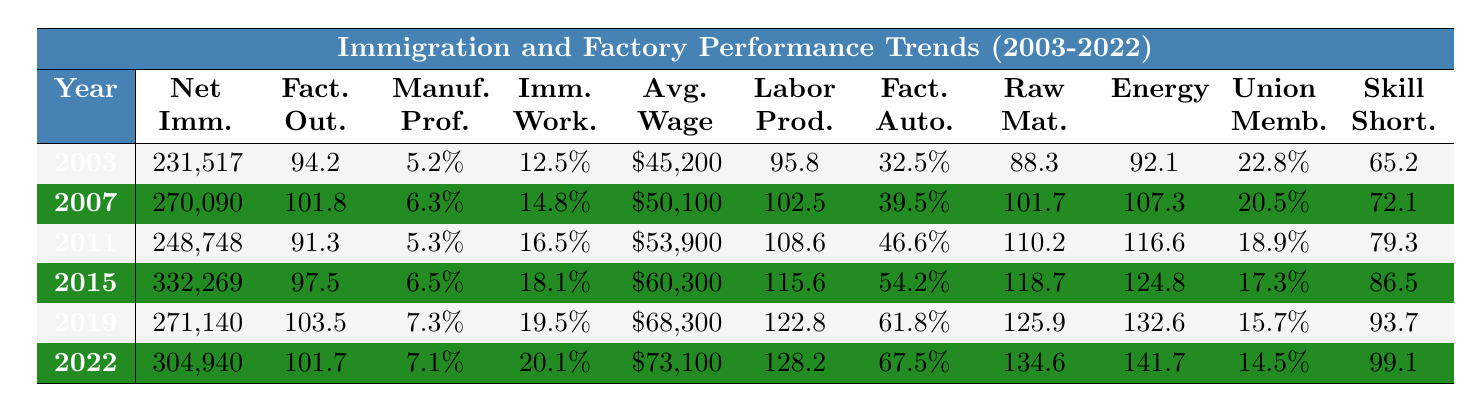What was the highest net immigration recorded in the table? The highest net immigration is found in 2015, which is 332,269.
Answer: 332,269 In which year did the factory output index reach its peak? To find the peak, we look for the highest value in the factory output index, which is 103.5 in 2019.
Answer: 2019 What is the average manufacturing profitability percentage from 2003 to 2022? The profitability percentages are added as follows: (5.2 + 5.5 + 5.7 + 6.1 + 6.3 + 5.8 + 4.2 + 4.9 + 5.3 + 5.6 + 5.9 + 6.2 + 6.5 + 6.7 + 7.0 + 7.2 + 7.3 + 6.1 + 6.8 + 7.1) = 128.4, then divided by 20 giving an average of 6.42%.
Answer: 6.42% Has the immigrant workforce percentage been consistently increasing? Examining the percentages shows they rose every year from 2003 (12.5%) to 2022 (20.1%) without any decrease.
Answer: Yes What was the percentage increase in the average wage for manufacturing from 2003 to 2022? The average wage in 2003 was $45,200 and in 2022 it was $73,100. Calculating the increase: (73100 - 45200) / 45200 * 100 = 61.8%.
Answer: 61.8% In which year did the labor productivity index first exceed 110? The labor productivity index exceeded 110 for the first time in 2011 when it reached 108.6, and remained above 110 from 2012 onward.
Answer: 2012 Is there a correlation between the increase in net immigration and the factory output index? Both the net immigration and factory output index data points show an overall upward trend over the years, suggesting a possible correlation, although direct calculation would be needed for confirmation.
Answer: Yes What was the trend of the skill shortage index over the years? The skill shortage index shows a steady increase from 65.2 in 2003 to 99.1 in 2022, indicating a worsening shortage of skilled labor.
Answer: Increasing What was the difference between the maximum and minimum raw material cost index from 2003 to 2022? The maximum raw material cost index is 134.6 (2022) and the minimum is 88.3 (2003). The difference is 134.6 - 88.3 = 46.3.
Answer: 46.3 What percentage of the labor force did trade union membership represent in 2003 compared to 2022? In 2003, trade union membership was 22.8%, and in 2022 it decreased to 14.5%. This shows a decline in union representation in percentage terms.
Answer: 22.8% to 14.5% How much did the factory automation level increase from 2003 to 2022? The factory automation level was 32.5% in 2003 and increased to 67.5% in 2022. The increase is 67.5 - 32.5 = 35%.
Answer: 35% 